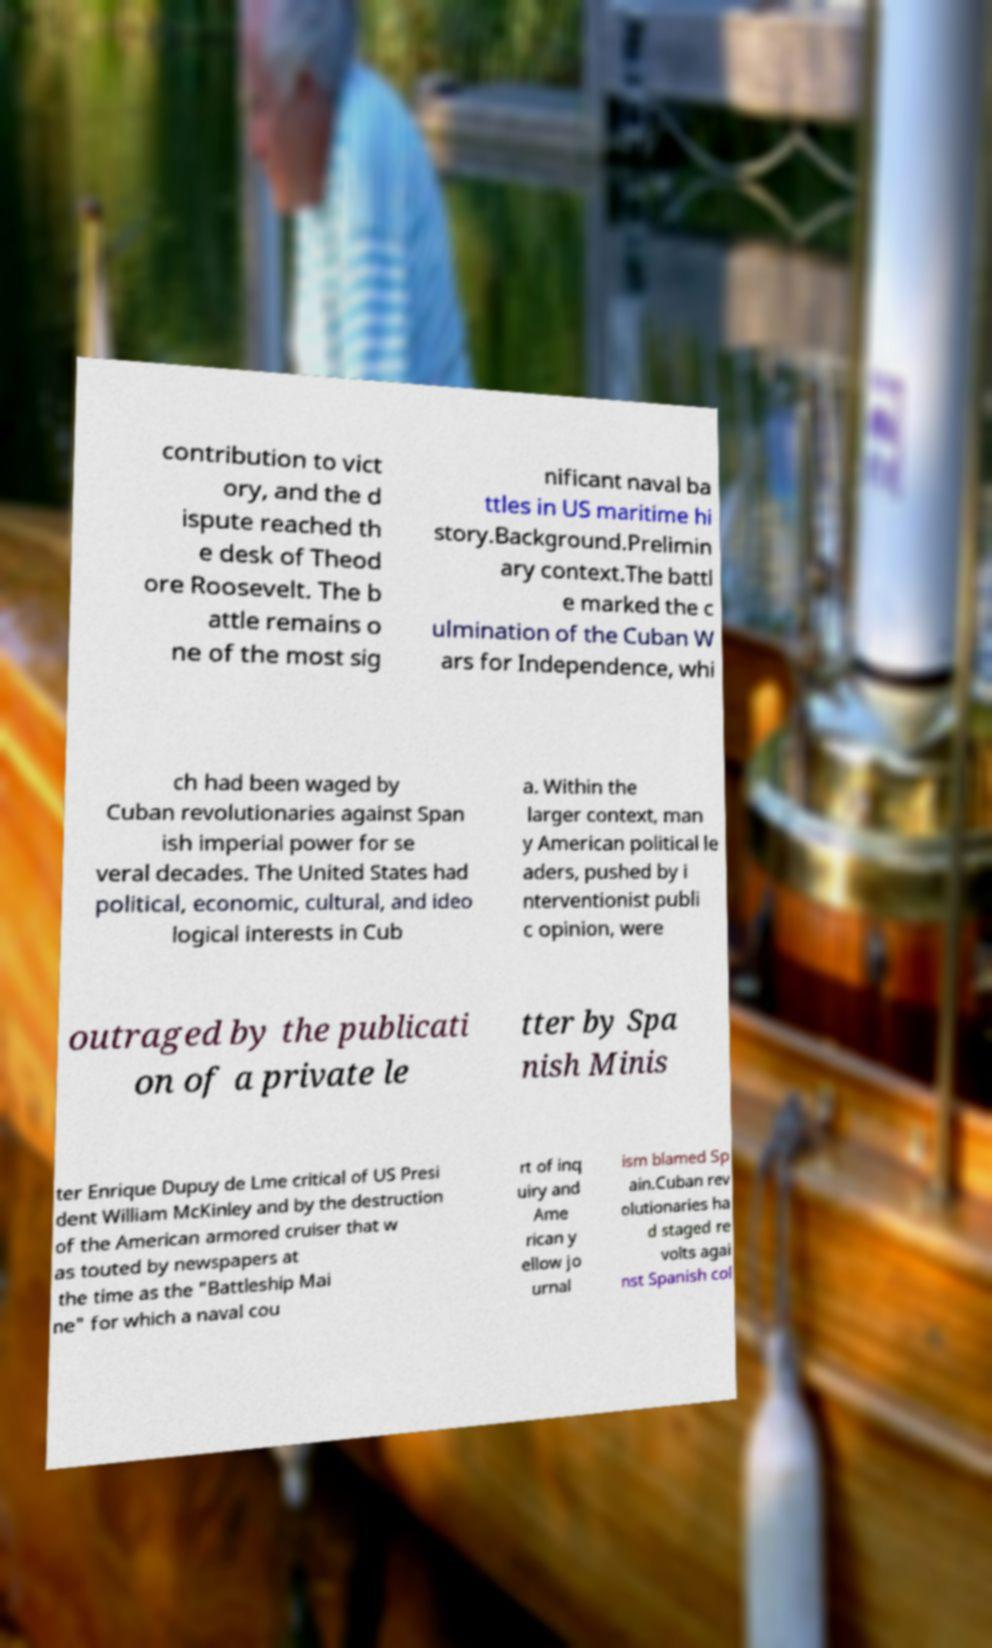Please read and relay the text visible in this image. What does it say? contribution to vict ory, and the d ispute reached th e desk of Theod ore Roosevelt. The b attle remains o ne of the most sig nificant naval ba ttles in US maritime hi story.Background.Prelimin ary context.The battl e marked the c ulmination of the Cuban W ars for Independence, whi ch had been waged by Cuban revolutionaries against Span ish imperial power for se veral decades. The United States had political, economic, cultural, and ideo logical interests in Cub a. Within the larger context, man y American political le aders, pushed by i nterventionist publi c opinion, were outraged by the publicati on of a private le tter by Spa nish Minis ter Enrique Dupuy de Lme critical of US Presi dent William McKinley and by the destruction of the American armored cruiser that w as touted by newspapers at the time as the "Battleship Mai ne" for which a naval cou rt of inq uiry and Ame rican y ellow jo urnal ism blamed Sp ain.Cuban rev olutionaries ha d staged re volts agai nst Spanish col 